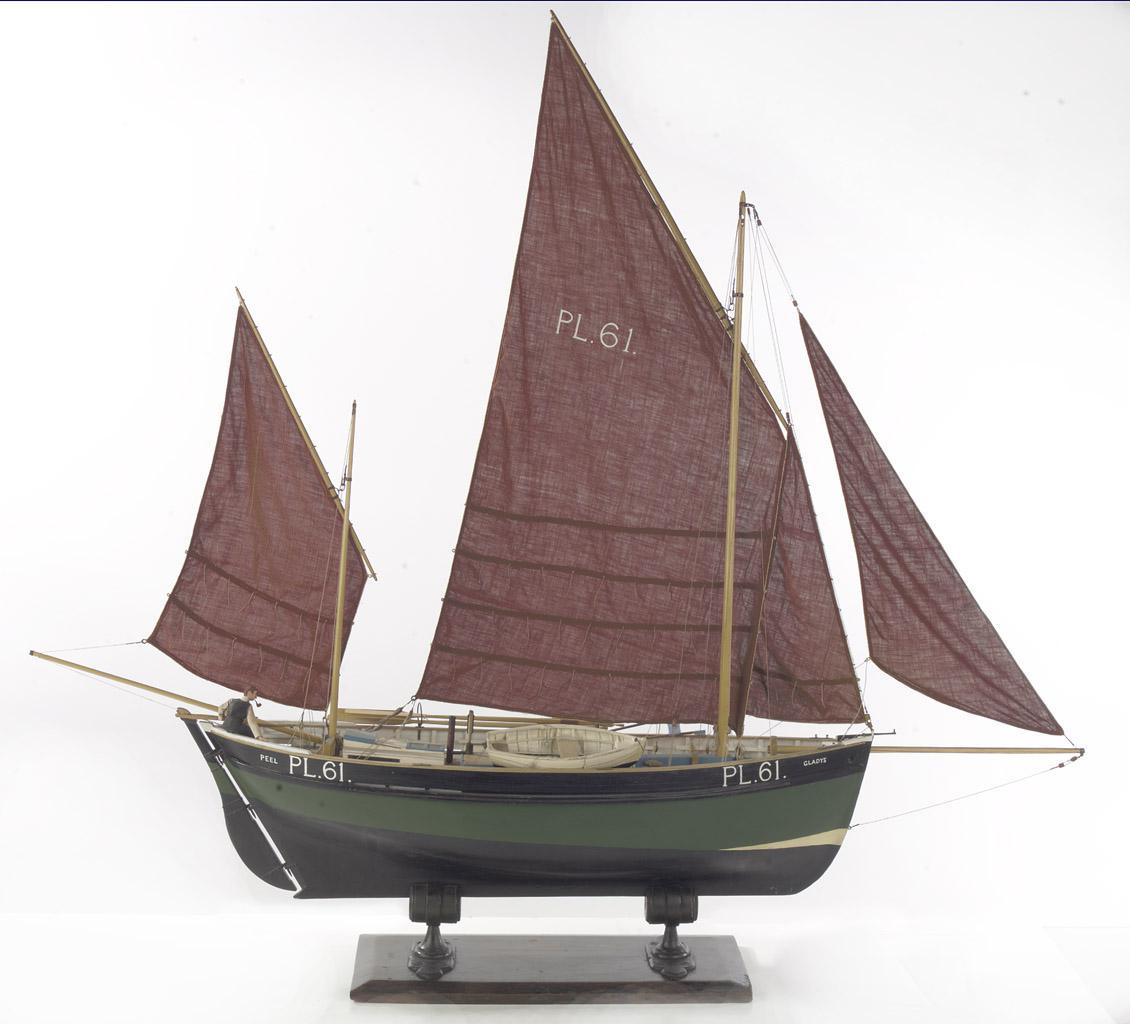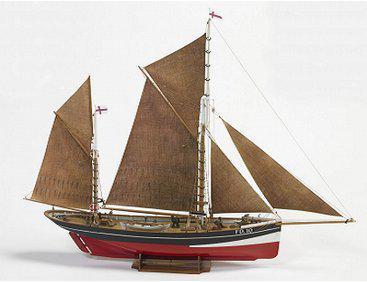The first image is the image on the left, the second image is the image on the right. For the images shown, is this caption "One of the boats has brown sails and a red bottom." true? Answer yes or no. Yes. 